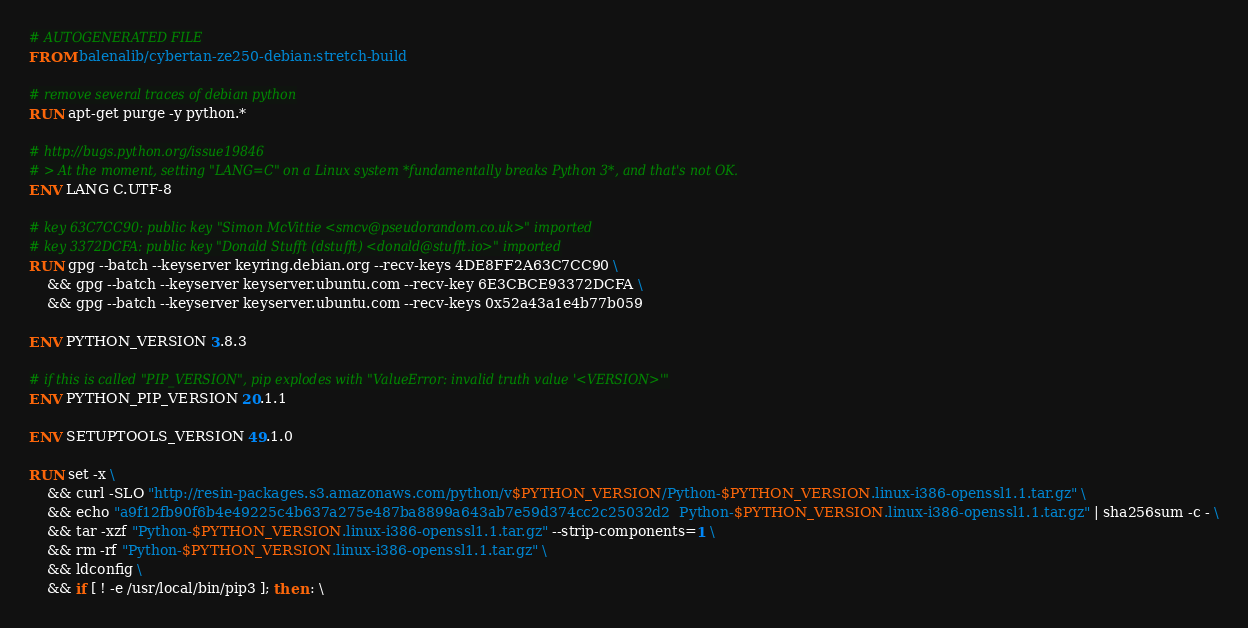<code> <loc_0><loc_0><loc_500><loc_500><_Dockerfile_># AUTOGENERATED FILE
FROM balenalib/cybertan-ze250-debian:stretch-build

# remove several traces of debian python
RUN apt-get purge -y python.*

# http://bugs.python.org/issue19846
# > At the moment, setting "LANG=C" on a Linux system *fundamentally breaks Python 3*, and that's not OK.
ENV LANG C.UTF-8

# key 63C7CC90: public key "Simon McVittie <smcv@pseudorandom.co.uk>" imported
# key 3372DCFA: public key "Donald Stufft (dstufft) <donald@stufft.io>" imported
RUN gpg --batch --keyserver keyring.debian.org --recv-keys 4DE8FF2A63C7CC90 \
	&& gpg --batch --keyserver keyserver.ubuntu.com --recv-key 6E3CBCE93372DCFA \
	&& gpg --batch --keyserver keyserver.ubuntu.com --recv-keys 0x52a43a1e4b77b059

ENV PYTHON_VERSION 3.8.3

# if this is called "PIP_VERSION", pip explodes with "ValueError: invalid truth value '<VERSION>'"
ENV PYTHON_PIP_VERSION 20.1.1

ENV SETUPTOOLS_VERSION 49.1.0

RUN set -x \
	&& curl -SLO "http://resin-packages.s3.amazonaws.com/python/v$PYTHON_VERSION/Python-$PYTHON_VERSION.linux-i386-openssl1.1.tar.gz" \
	&& echo "a9f12fb90f6b4e49225c4b637a275e487ba8899a643ab7e59d374cc2c25032d2  Python-$PYTHON_VERSION.linux-i386-openssl1.1.tar.gz" | sha256sum -c - \
	&& tar -xzf "Python-$PYTHON_VERSION.linux-i386-openssl1.1.tar.gz" --strip-components=1 \
	&& rm -rf "Python-$PYTHON_VERSION.linux-i386-openssl1.1.tar.gz" \
	&& ldconfig \
	&& if [ ! -e /usr/local/bin/pip3 ]; then : \</code> 